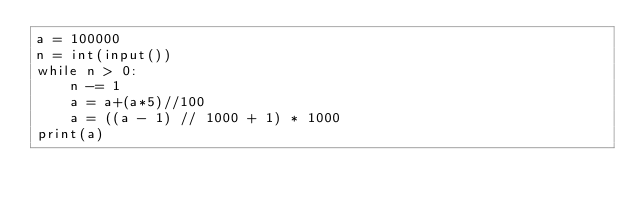Convert code to text. <code><loc_0><loc_0><loc_500><loc_500><_Python_>a = 100000
n = int(input())
while n > 0:
    n -= 1
    a = a+(a*5)//100
    a = ((a - 1) // 1000 + 1) * 1000 
print(a)
</code> 